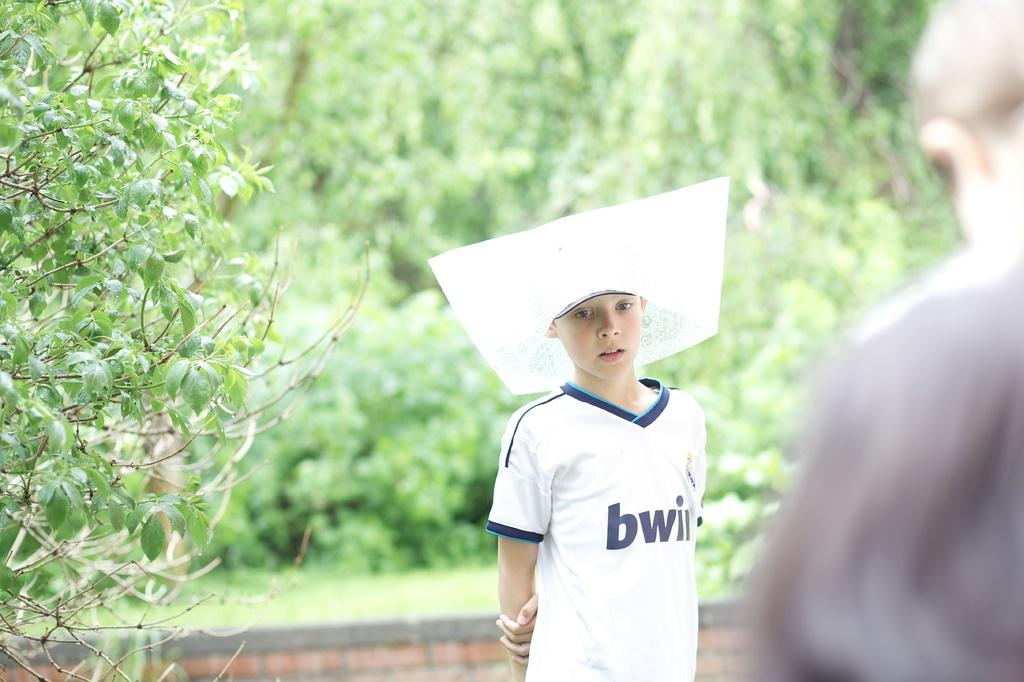<image>
Describe the image concisely. A young man wearing a bwin shirt poses for the camera. 